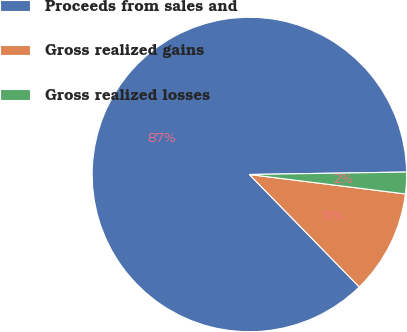<chart> <loc_0><loc_0><loc_500><loc_500><pie_chart><fcel>Proceeds from sales and<fcel>Gross realized gains<fcel>Gross realized losses<nl><fcel>87.07%<fcel>10.71%<fcel>2.22%<nl></chart> 